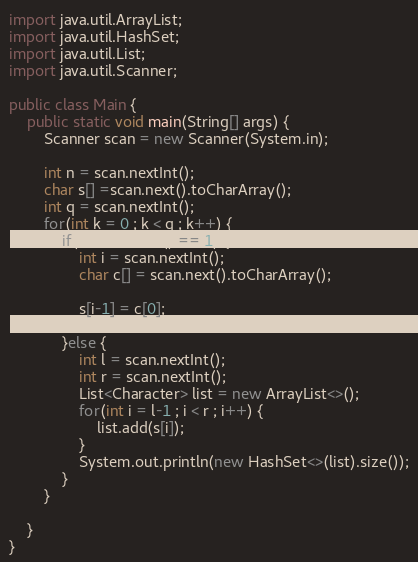<code> <loc_0><loc_0><loc_500><loc_500><_Java_>import java.util.ArrayList;
import java.util.HashSet;
import java.util.List;
import java.util.Scanner;

public class Main {
	public static void main(String[] args) {
		Scanner scan = new Scanner(System.in);

		int n = scan.nextInt();
		char s[] =scan.next().toCharArray();
		int q = scan.nextInt();
		for(int k = 0 ; k < q ; k++) {
			if(scan.nextInt() == 1) {
				int i = scan.nextInt();
				char c[] = scan.next().toCharArray();

				s[i-1] = c[0];

			}else {
				int l = scan.nextInt();
				int r = scan.nextInt();
				List<Character> list = new ArrayList<>();
				for(int i = l-1 ; i < r ; i++) {
					list.add(s[i]);
				}
				System.out.println(new HashSet<>(list).size());
			}
		}

	}
}
</code> 